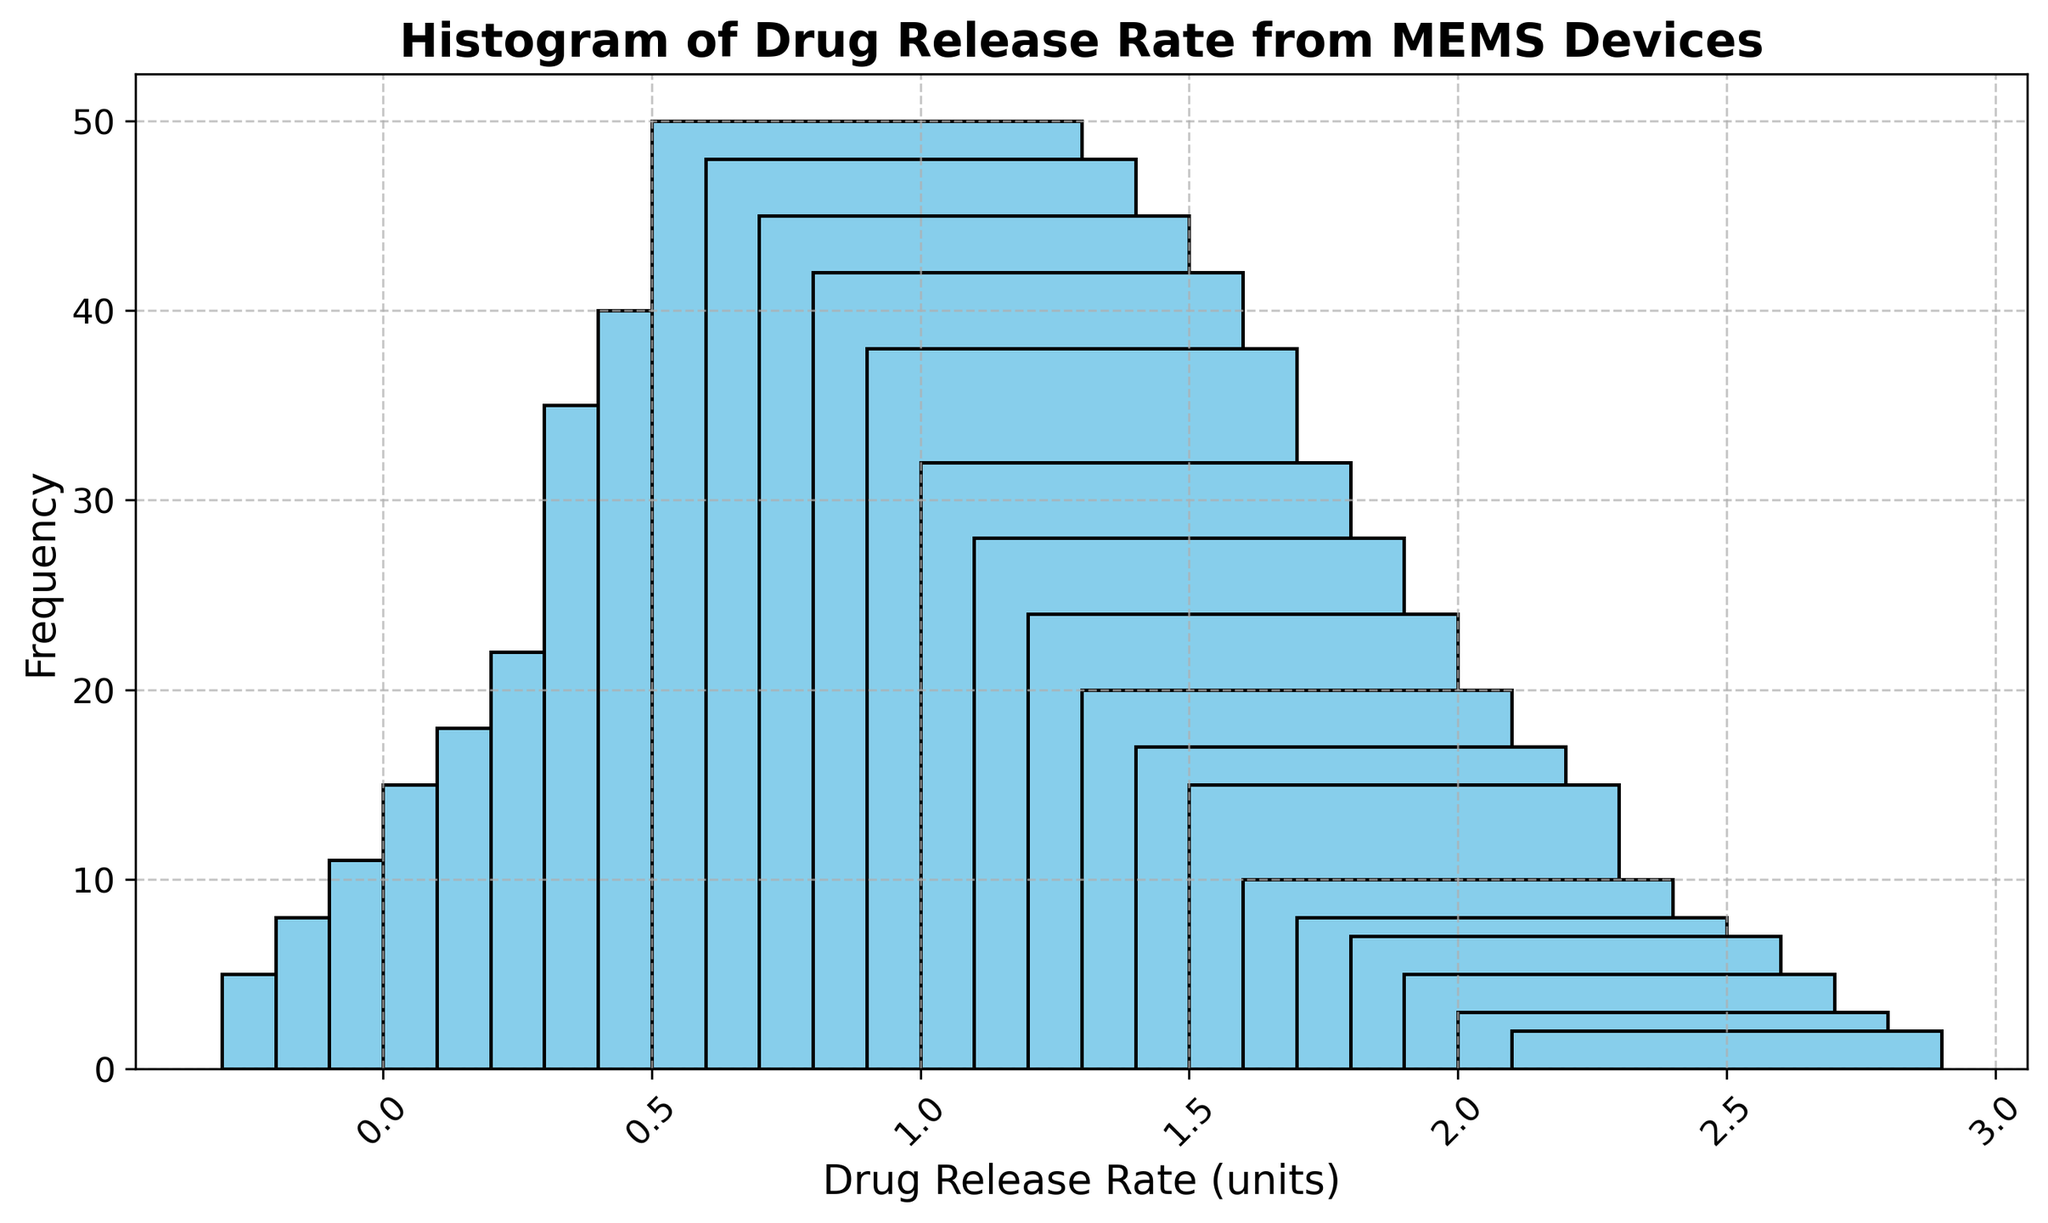What drug release rate has the highest frequency? According to the histogram, the tallest bar represents the drug release rate with the highest frequency. By visually inspecting the bars, the drug release rate of 0.9 has the highest frequency of 50.
Answer: 0.9 What is the total frequency for drug release rates from 0.6 to 1.0? The frequencies for the drug release rates in the range 0.6 to 1.0 are 22, 35, 40, 50, and 48. Adding these values gives: 22 + 35 + 40 + 50 + 48 = 195.
Answer: 195 How many drug release rates have a frequency greater than or equal to 40? By examining the histogram, the frequencies greater than or equal to 40 are for the drug release rates 0.8, 0.9, 1.0, 1.1, and 1.2. This counts to 5 drug release rates.
Answer: 5 Which drug release rate range (from a set like 0.5-1.0 and 1.0-1.5) has a higher total frequency? The frequencies for 0.5-1.0 are 18, 22, 35, 40, 50, and the frequencies for 1.0-1.5 are 48, 45, 42, 38, 32. Summing these, we get 0.5-1.0: 18 + 22 + 35 + 40 + 50 = 165, and 1.0-1.5: 48 + 45 + 42 + 38 + 32 = 205. Clearly, the 1.0-1.5 range has a higher total frequency.
Answer: 1.0-1.5 What's the average frequency for drug release rates from 0.1 to 0.5? The frequencies for 0.1 to 0.5 are 5, 8, 11, 15, 18. The average frequency is therefore (5 + 8 + 11 + 15 + 18) / 5 = 57 / 5 = 11.4.
Answer: 11.4 Which two consecutive drug release rate intervals have the most significant difference in frequency? To determine this, examine the absolute differences between consecutive frequencies: 8-5=3, 11-8=3, 15-11=4, 18-15=3, 22-18=4, 35-22=13, 40-35=5, 50-40=10, 48-50=2, 45-48=3, 42-45=3, 38-42=4, 32-38=6, 28-32=4, 24-28=4, 20-24=4, 17-20=3, 15-17=2, 10-15=5, 8-10=2, 7-8=1, 5-7=2, 3-5=2, 2-3=1. The maximum difference of 13 is between the drug release rates of 0.6 and 0.7.
Answer: 0.6 and 0.7 